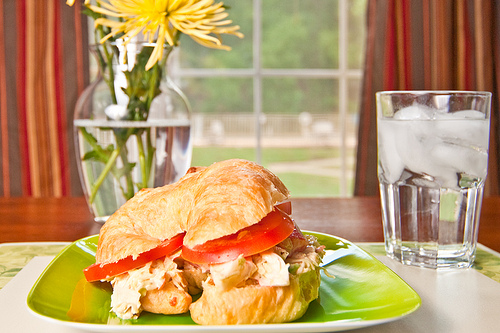What would be a perfect meal to accompany this setting? A perfect meal to accompany this setting would include a fresh garden salad with a variety of vegetables like cucumbers, bell peppers, and avocado. For a side, perhaps some sweet potato fries or a small bowl of fruit salad. To drink, a refreshing glass of iced tea or lemonade would complement the meal wonderfully. Ending with a slice of light lemon cake or fruit tart would make it perfect. 